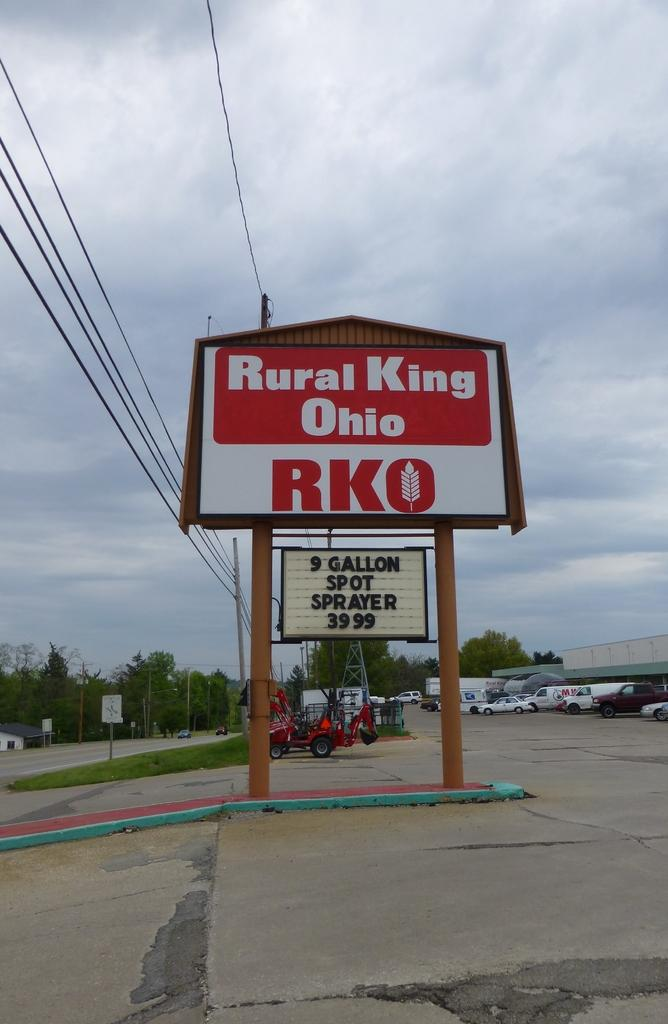Provide a one-sentence caption for the provided image. A Rural King Ohio sign advertising a spot sprayer.. 